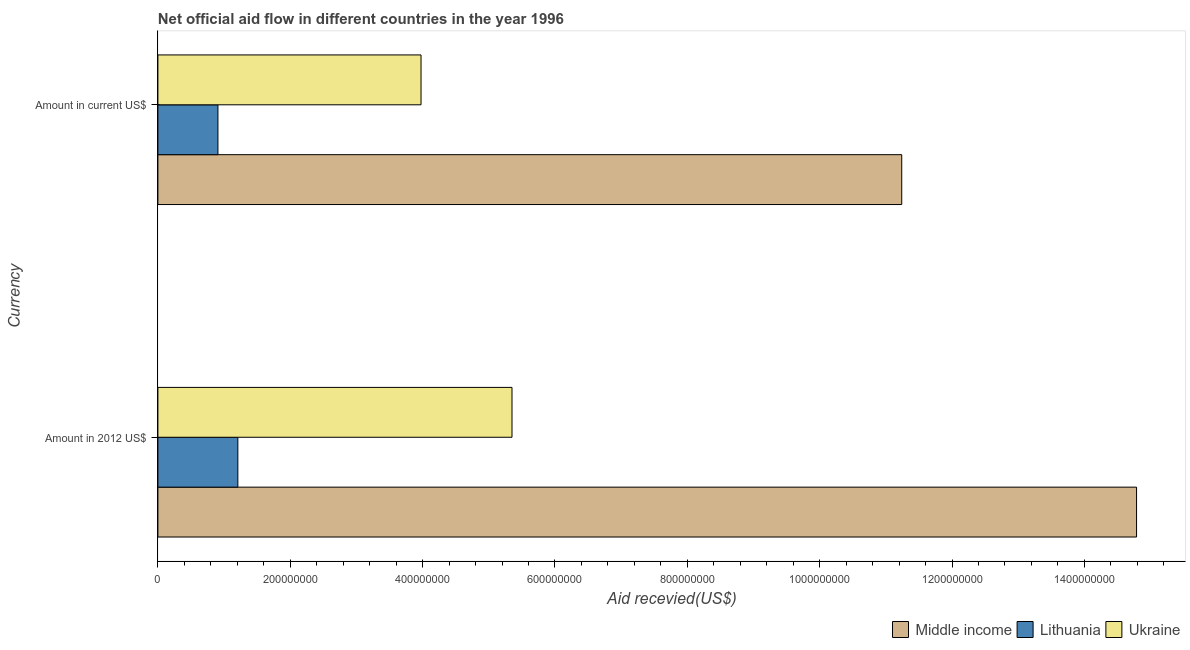What is the label of the 2nd group of bars from the top?
Keep it short and to the point. Amount in 2012 US$. What is the amount of aid received(expressed in 2012 us$) in Middle income?
Keep it short and to the point. 1.48e+09. Across all countries, what is the maximum amount of aid received(expressed in us$)?
Give a very brief answer. 1.12e+09. Across all countries, what is the minimum amount of aid received(expressed in 2012 us$)?
Your response must be concise. 1.21e+08. In which country was the amount of aid received(expressed in us$) minimum?
Offer a terse response. Lithuania. What is the total amount of aid received(expressed in us$) in the graph?
Make the answer very short. 1.61e+09. What is the difference between the amount of aid received(expressed in us$) in Middle income and that in Lithuania?
Your answer should be very brief. 1.03e+09. What is the difference between the amount of aid received(expressed in us$) in Lithuania and the amount of aid received(expressed in 2012 us$) in Middle income?
Make the answer very short. -1.39e+09. What is the average amount of aid received(expressed in us$) per country?
Provide a short and direct response. 5.37e+08. What is the difference between the amount of aid received(expressed in us$) and amount of aid received(expressed in 2012 us$) in Lithuania?
Offer a very short reply. -3.01e+07. In how many countries, is the amount of aid received(expressed in 2012 us$) greater than 200000000 US$?
Offer a terse response. 2. What is the ratio of the amount of aid received(expressed in us$) in Lithuania to that in Ukraine?
Offer a terse response. 0.23. Is the amount of aid received(expressed in 2012 us$) in Ukraine less than that in Middle income?
Keep it short and to the point. Yes. What does the 1st bar from the top in Amount in current US$ represents?
Your answer should be compact. Ukraine. What does the 2nd bar from the bottom in Amount in current US$ represents?
Provide a short and direct response. Lithuania. How many bars are there?
Your answer should be very brief. 6. Are the values on the major ticks of X-axis written in scientific E-notation?
Your answer should be compact. No. Does the graph contain any zero values?
Provide a short and direct response. No. Does the graph contain grids?
Provide a short and direct response. No. Where does the legend appear in the graph?
Keep it short and to the point. Bottom right. What is the title of the graph?
Offer a terse response. Net official aid flow in different countries in the year 1996. What is the label or title of the X-axis?
Make the answer very short. Aid recevied(US$). What is the label or title of the Y-axis?
Ensure brevity in your answer.  Currency. What is the Aid recevied(US$) in Middle income in Amount in 2012 US$?
Make the answer very short. 1.48e+09. What is the Aid recevied(US$) in Lithuania in Amount in 2012 US$?
Offer a terse response. 1.21e+08. What is the Aid recevied(US$) of Ukraine in Amount in 2012 US$?
Your answer should be very brief. 5.35e+08. What is the Aid recevied(US$) in Middle income in Amount in current US$?
Ensure brevity in your answer.  1.12e+09. What is the Aid recevied(US$) of Lithuania in Amount in current US$?
Make the answer very short. 9.07e+07. What is the Aid recevied(US$) in Ukraine in Amount in current US$?
Offer a very short reply. 3.98e+08. Across all Currency, what is the maximum Aid recevied(US$) of Middle income?
Your answer should be compact. 1.48e+09. Across all Currency, what is the maximum Aid recevied(US$) of Lithuania?
Offer a very short reply. 1.21e+08. Across all Currency, what is the maximum Aid recevied(US$) in Ukraine?
Your answer should be very brief. 5.35e+08. Across all Currency, what is the minimum Aid recevied(US$) in Middle income?
Give a very brief answer. 1.12e+09. Across all Currency, what is the minimum Aid recevied(US$) of Lithuania?
Your answer should be very brief. 9.07e+07. Across all Currency, what is the minimum Aid recevied(US$) in Ukraine?
Give a very brief answer. 3.98e+08. What is the total Aid recevied(US$) in Middle income in the graph?
Provide a succinct answer. 2.60e+09. What is the total Aid recevied(US$) of Lithuania in the graph?
Keep it short and to the point. 2.12e+08. What is the total Aid recevied(US$) of Ukraine in the graph?
Offer a very short reply. 9.33e+08. What is the difference between the Aid recevied(US$) in Middle income in Amount in 2012 US$ and that in Amount in current US$?
Make the answer very short. 3.55e+08. What is the difference between the Aid recevied(US$) of Lithuania in Amount in 2012 US$ and that in Amount in current US$?
Offer a very short reply. 3.01e+07. What is the difference between the Aid recevied(US$) in Ukraine in Amount in 2012 US$ and that in Amount in current US$?
Your response must be concise. 1.37e+08. What is the difference between the Aid recevied(US$) of Middle income in Amount in 2012 US$ and the Aid recevied(US$) of Lithuania in Amount in current US$?
Keep it short and to the point. 1.39e+09. What is the difference between the Aid recevied(US$) of Middle income in Amount in 2012 US$ and the Aid recevied(US$) of Ukraine in Amount in current US$?
Offer a very short reply. 1.08e+09. What is the difference between the Aid recevied(US$) of Lithuania in Amount in 2012 US$ and the Aid recevied(US$) of Ukraine in Amount in current US$?
Your answer should be compact. -2.77e+08. What is the average Aid recevied(US$) in Middle income per Currency?
Offer a terse response. 1.30e+09. What is the average Aid recevied(US$) of Lithuania per Currency?
Give a very brief answer. 1.06e+08. What is the average Aid recevied(US$) in Ukraine per Currency?
Provide a short and direct response. 4.66e+08. What is the difference between the Aid recevied(US$) of Middle income and Aid recevied(US$) of Lithuania in Amount in 2012 US$?
Provide a succinct answer. 1.36e+09. What is the difference between the Aid recevied(US$) in Middle income and Aid recevied(US$) in Ukraine in Amount in 2012 US$?
Give a very brief answer. 9.44e+08. What is the difference between the Aid recevied(US$) in Lithuania and Aid recevied(US$) in Ukraine in Amount in 2012 US$?
Offer a terse response. -4.14e+08. What is the difference between the Aid recevied(US$) of Middle income and Aid recevied(US$) of Lithuania in Amount in current US$?
Make the answer very short. 1.03e+09. What is the difference between the Aid recevied(US$) of Middle income and Aid recevied(US$) of Ukraine in Amount in current US$?
Give a very brief answer. 7.26e+08. What is the difference between the Aid recevied(US$) in Lithuania and Aid recevied(US$) in Ukraine in Amount in current US$?
Your answer should be very brief. -3.07e+08. What is the ratio of the Aid recevied(US$) in Middle income in Amount in 2012 US$ to that in Amount in current US$?
Make the answer very short. 1.32. What is the ratio of the Aid recevied(US$) of Lithuania in Amount in 2012 US$ to that in Amount in current US$?
Offer a very short reply. 1.33. What is the ratio of the Aid recevied(US$) of Ukraine in Amount in 2012 US$ to that in Amount in current US$?
Give a very brief answer. 1.35. What is the difference between the highest and the second highest Aid recevied(US$) of Middle income?
Offer a terse response. 3.55e+08. What is the difference between the highest and the second highest Aid recevied(US$) of Lithuania?
Provide a short and direct response. 3.01e+07. What is the difference between the highest and the second highest Aid recevied(US$) of Ukraine?
Your response must be concise. 1.37e+08. What is the difference between the highest and the lowest Aid recevied(US$) in Middle income?
Give a very brief answer. 3.55e+08. What is the difference between the highest and the lowest Aid recevied(US$) of Lithuania?
Provide a short and direct response. 3.01e+07. What is the difference between the highest and the lowest Aid recevied(US$) of Ukraine?
Your answer should be very brief. 1.37e+08. 